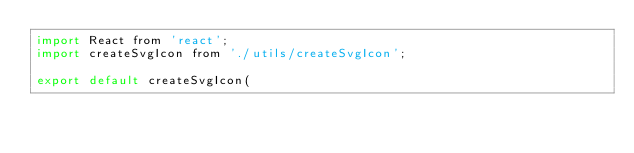<code> <loc_0><loc_0><loc_500><loc_500><_JavaScript_>import React from 'react';
import createSvgIcon from './utils/createSvgIcon';

export default createSvgIcon(</code> 